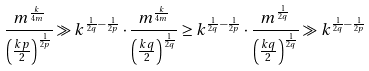Convert formula to latex. <formula><loc_0><loc_0><loc_500><loc_500>\frac { m ^ { \frac { k } { 4 m } } } { \left ( \frac { k p } { 2 } \right ) ^ { \frac { 1 } { 2 p } } } \gg k ^ { \frac { 1 } { 2 q } - \frac { 1 } { 2 p } } \cdot \frac { m ^ { \frac { k } { 4 m } } } { \left ( \frac { k q } { 2 } \right ) ^ { \frac { 1 } { 2 q } } } \geq k ^ { \frac { 1 } { 2 q } - \frac { 1 } { 2 p } } \cdot \frac { m ^ { \frac { 1 } { 2 q } } } { \left ( \frac { k q } { 2 } \right ) ^ { \frac { 1 } { 2 q } } } \gg k ^ { \frac { 1 } { 2 q } - \frac { 1 } { 2 p } }</formula> 